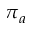<formula> <loc_0><loc_0><loc_500><loc_500>\pi _ { a }</formula> 